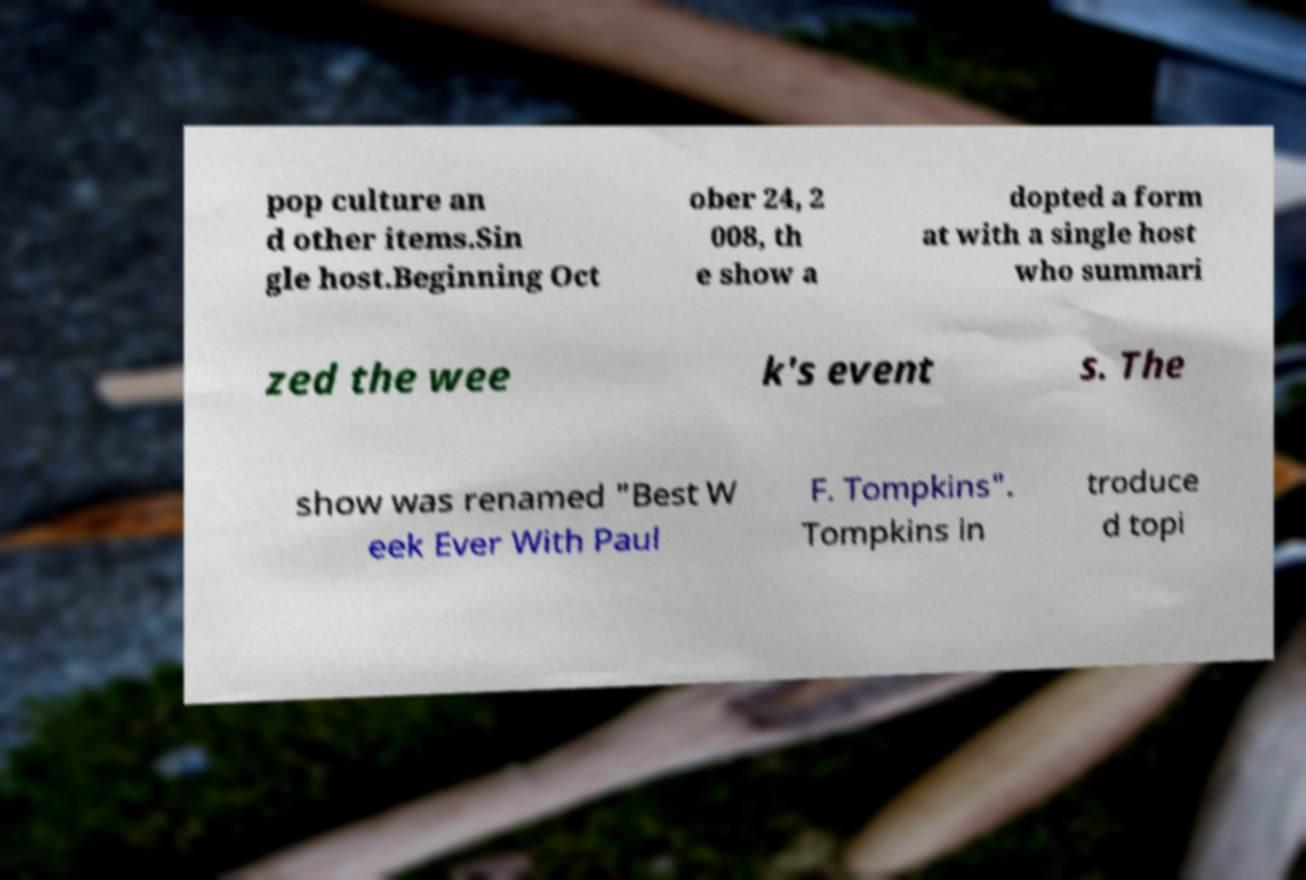Could you extract and type out the text from this image? pop culture an d other items.Sin gle host.Beginning Oct ober 24, 2 008, th e show a dopted a form at with a single host who summari zed the wee k's event s. The show was renamed "Best W eek Ever With Paul F. Tompkins". Tompkins in troduce d topi 